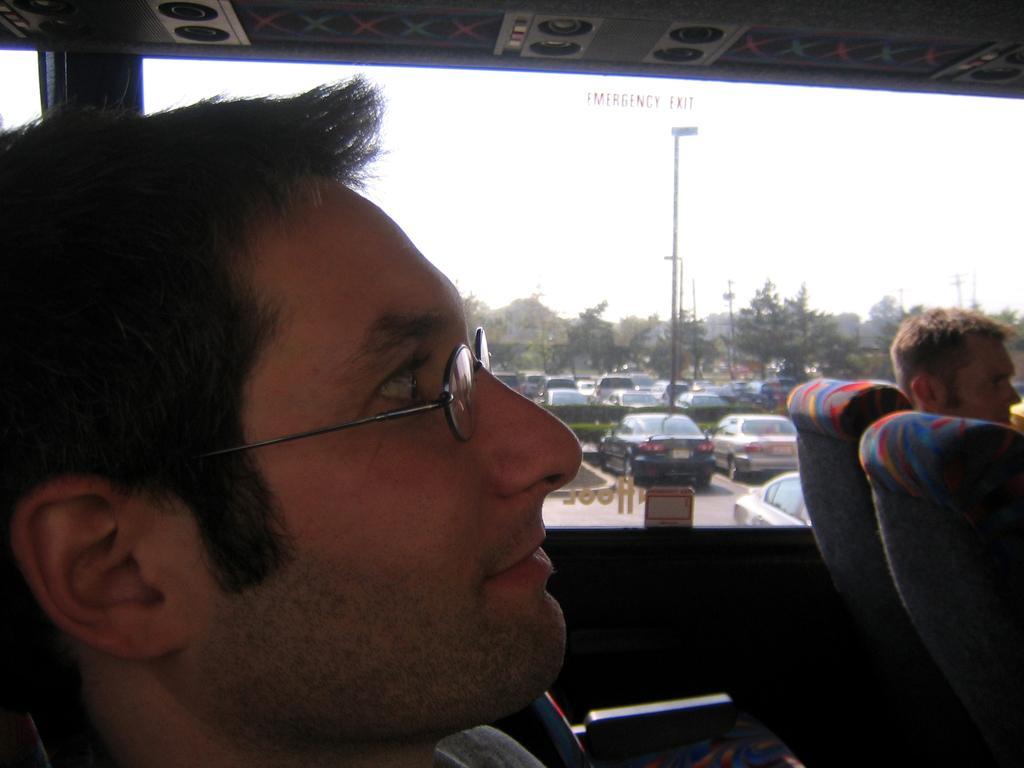Please provide a concise description of this image. In this image we can see the inside view of a vehicle. In this image we can see persons, seats, glass window and other objects. Behind the glass window there are trees, poles, vehicles, sky and other objects. 